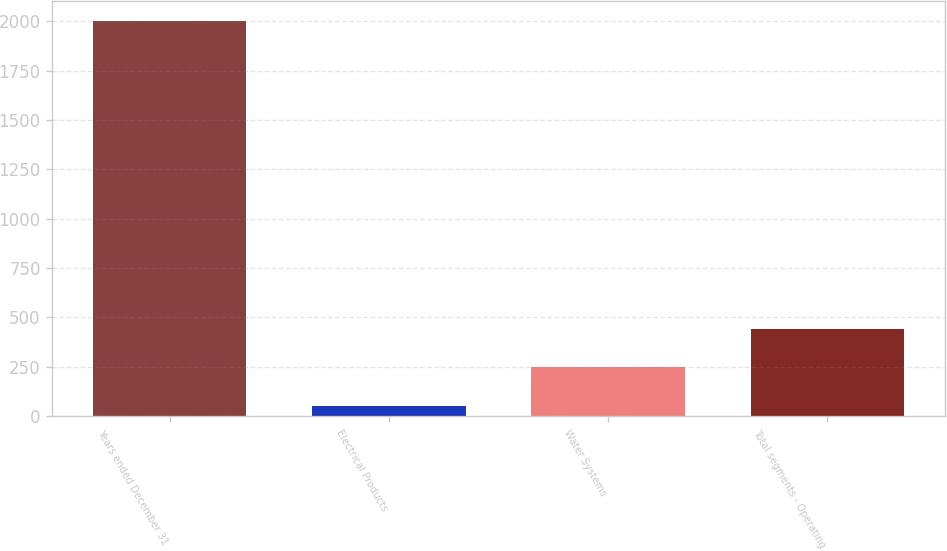<chart> <loc_0><loc_0><loc_500><loc_500><bar_chart><fcel>Years ended December 31<fcel>Electrical Products<fcel>Water Systems<fcel>Total segments - Operating<nl><fcel>2003<fcel>54.2<fcel>249.08<fcel>443.96<nl></chart> 